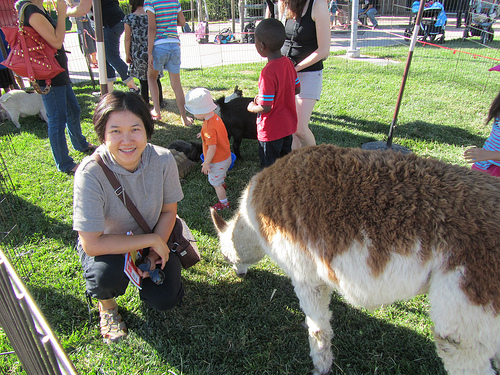What else can you see in the background besides the main subjects? In the background, you can observe more visitors at the petting zoo, including other children and adults. There are additional animals within the fenced area, engaging with everyone around them. Also visible are parts of the zoo's structure, such as fencing and possibly some signs or barriers, that help contain and manage both the animals and the onlookers. The atmosphere appears to be vibrant and engaging, with many individuals enjoying their interactions with the animals. Give a plausible scenario of what might happen next in this image. In the next moment, the children might start feeding the animals with the food provided by the petting zoo staff. The boy in the red shirt could laugh joyfully as the friendly llama, Sir Fluffington, nuzzles up to his hand, gently taking the food. The woman squatting nearby might take some photographs, capturing these precious moments. Meanwhile, more families might enter the petting area, adding to the lively atmosphere and creating a sense of community and shared joy in this serene setting. Describe a relaxing, end-of-day scene in this place. As the day draws to a close at the petting zoo, the hustle and bustle slowly diminishes. The setting sun casts a warm, golden glow over the grassy area, creating a tranquil ambiance. The children and their families gradually make their way to the exit, many holding souvenirs or mementos of their visit. The animals, having enjoyed a day of interactions, begin to settle down, some lying in the grass or retreating to their cozy enclosures. The sounds of laughter and excitement give way to a peaceful silence, punctuated only by the soft rustling of leaves and the occasional animal call. The caretakers walk through the area, ensuring everything is in order and preparing for the next day. There's a sense of satisfaction and contentment in the air, as everyone leaves with happy memories of their time spent in this charming, heartwarming place. 